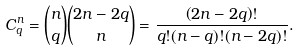Convert formula to latex. <formula><loc_0><loc_0><loc_500><loc_500>C _ { q } ^ { n } = \binom { n } { q } \binom { 2 n - 2 q } { n } = \frac { \left ( 2 n - 2 q \right ) ! } { q ! ( n - q ) ! ( n - 2 q ) ! } .</formula> 